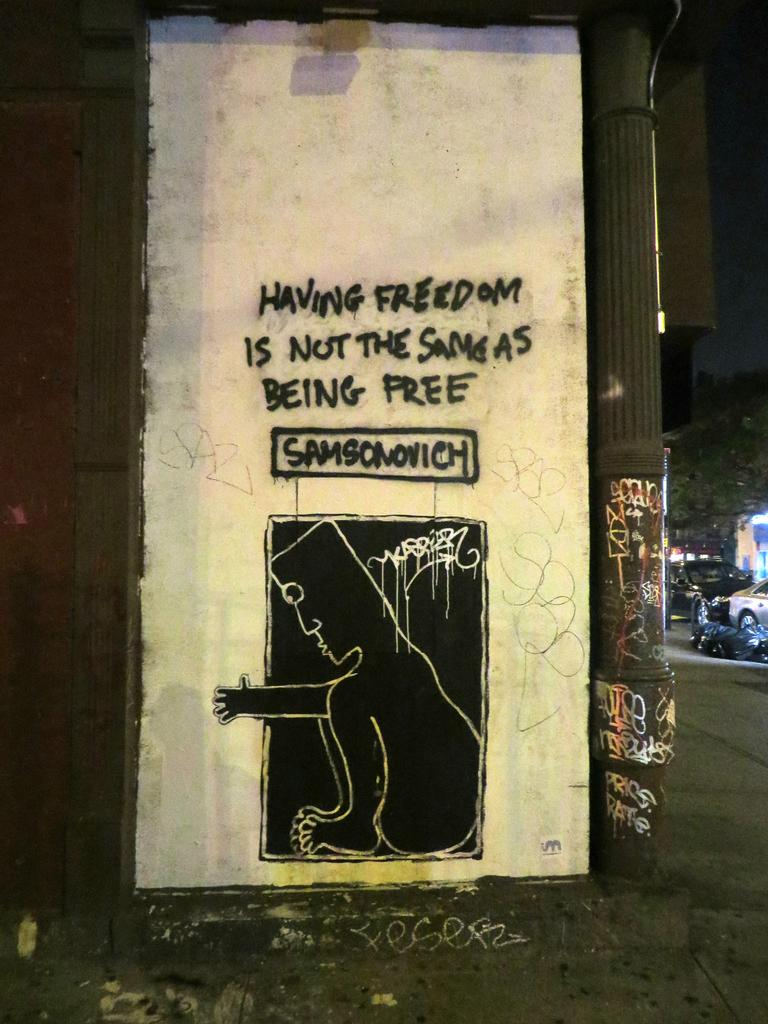<image>
Write a terse but informative summary of the picture. Street art that says Having Freedom is Not the Same As Being Free. 